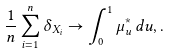<formula> <loc_0><loc_0><loc_500><loc_500>\frac { 1 } { n } \sum _ { i = 1 } ^ { n } \delta _ { X _ { i } } \to \int _ { 0 } ^ { 1 } \mu ^ { * } _ { u } \, d u , .</formula> 